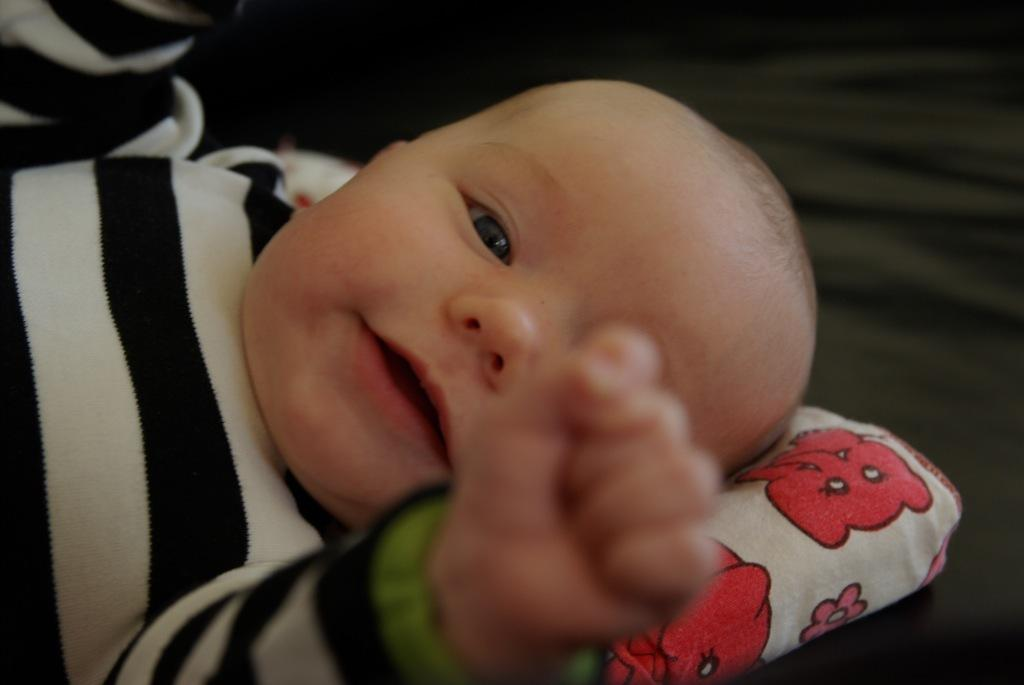What is the main subject of the image? There is a baby in the image. Where is the baby positioned in the image? The baby is on a pillow. Can you describe the background of the image? The background of the image is blurred. What type of whistle can be heard in the background of the image? There is no whistle present in the image, as it is a still photograph. 